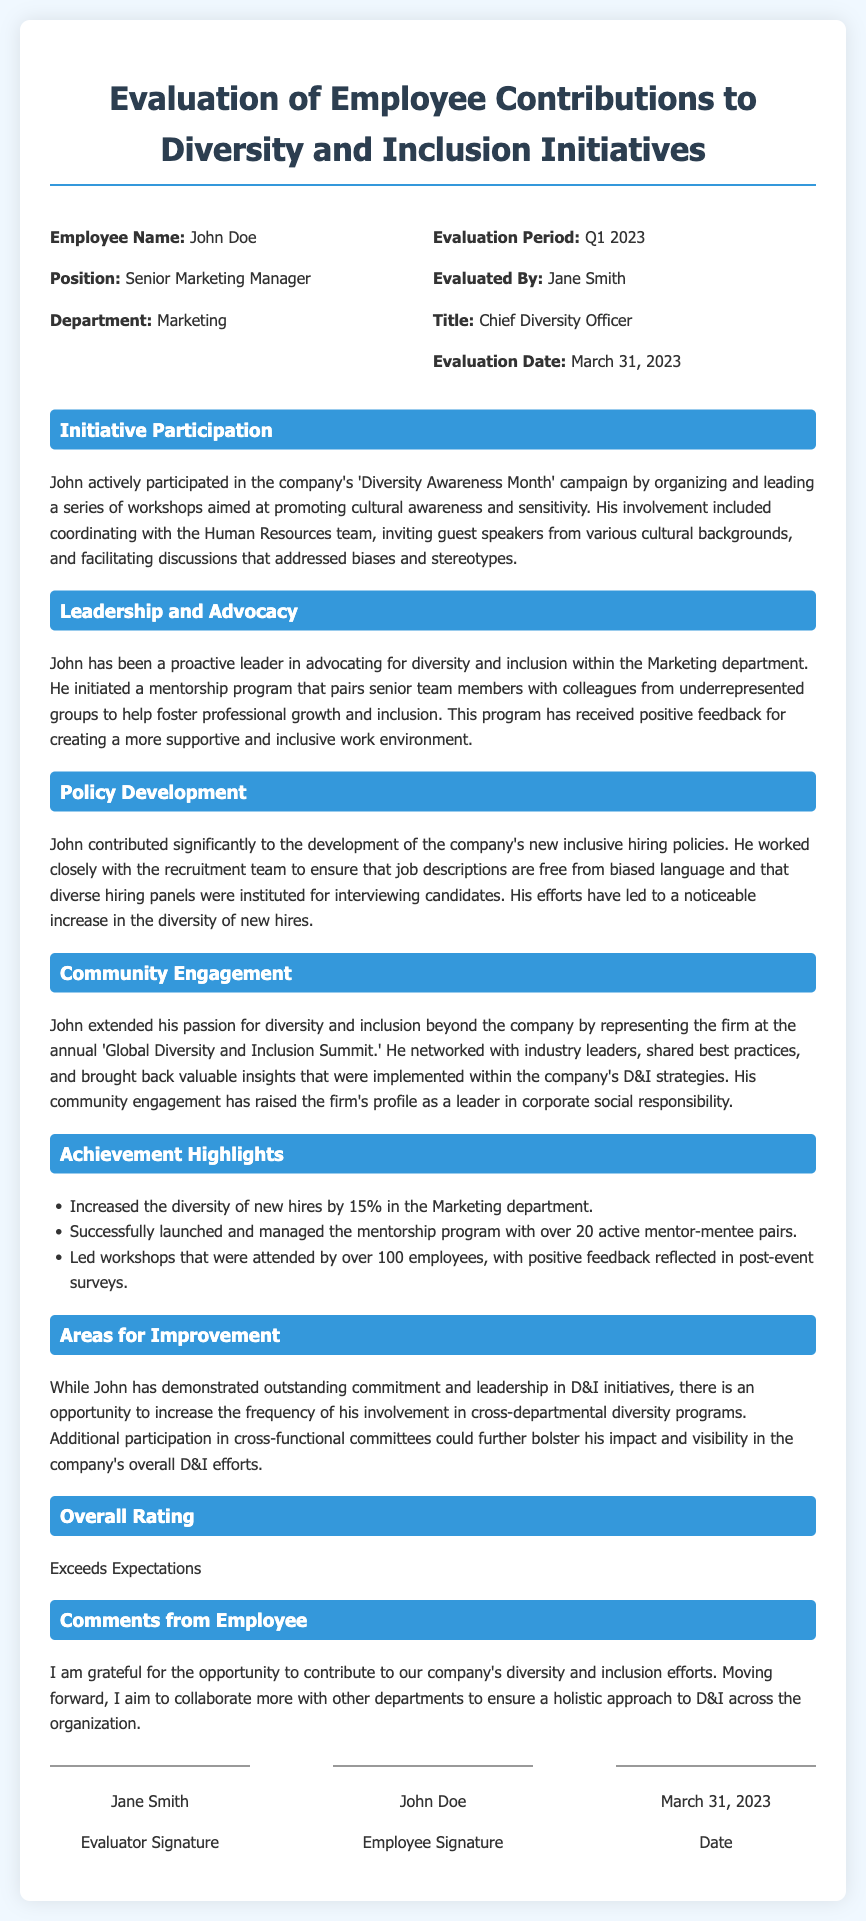What is the employee's name? The document states that the employee's name is John Doe.
Answer: John Doe Who evaluated the employee? The evaluator's name and title are mentioned as Jane Smith and Chief Diversity Officer, respectively.
Answer: Jane Smith What position does the employee hold? The document specifies that John is a Senior Marketing Manager.
Answer: Senior Marketing Manager What is the evaluation period? The evaluation period is stated as Q1 2023 in the document.
Answer: Q1 2023 How did John contribute to policy development? The document mentions that John worked closely with the recruitment team to enhance inclusive hiring policies.
Answer: Inclusive hiring policies What was one of John's achievements in the Marketing department? The appraisal highlights that he increased diversity of new hires by 15%.
Answer: 15% What future goal did John express in his comments? John's comments indicate his aim to collaborate more with other departments on D&I efforts.
Answer: Collaborate more What aspect of John's participation is identified for improvement? The appraisal suggests increasing his involvement in cross-departmental diversity programs.
Answer: Cross-departmental diversity programs What was the overall rating given to John? The document states that John's overall rating is "Exceeds Expectations."
Answer: Exceeds Expectations 